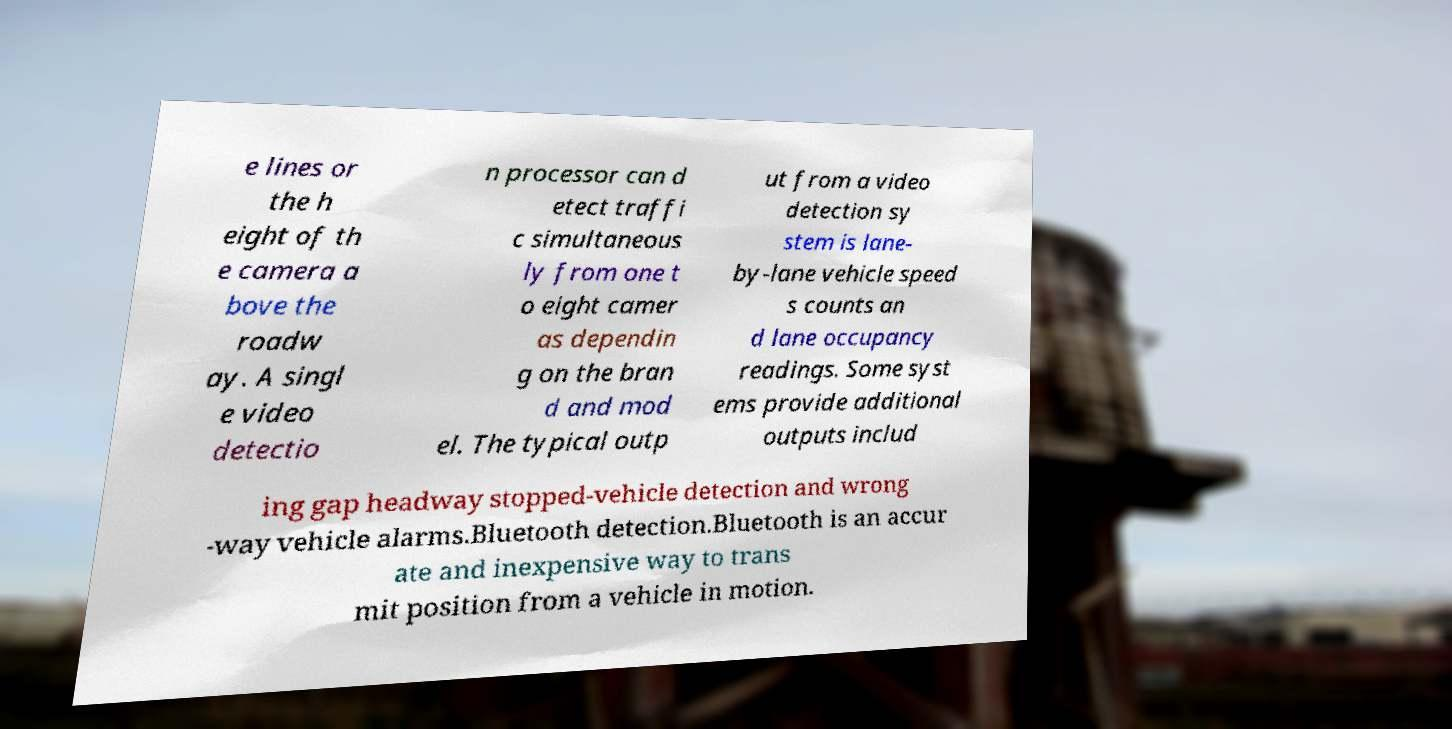Please read and relay the text visible in this image. What does it say? e lines or the h eight of th e camera a bove the roadw ay. A singl e video detectio n processor can d etect traffi c simultaneous ly from one t o eight camer as dependin g on the bran d and mod el. The typical outp ut from a video detection sy stem is lane- by-lane vehicle speed s counts an d lane occupancy readings. Some syst ems provide additional outputs includ ing gap headway stopped-vehicle detection and wrong -way vehicle alarms.Bluetooth detection.Bluetooth is an accur ate and inexpensive way to trans mit position from a vehicle in motion. 